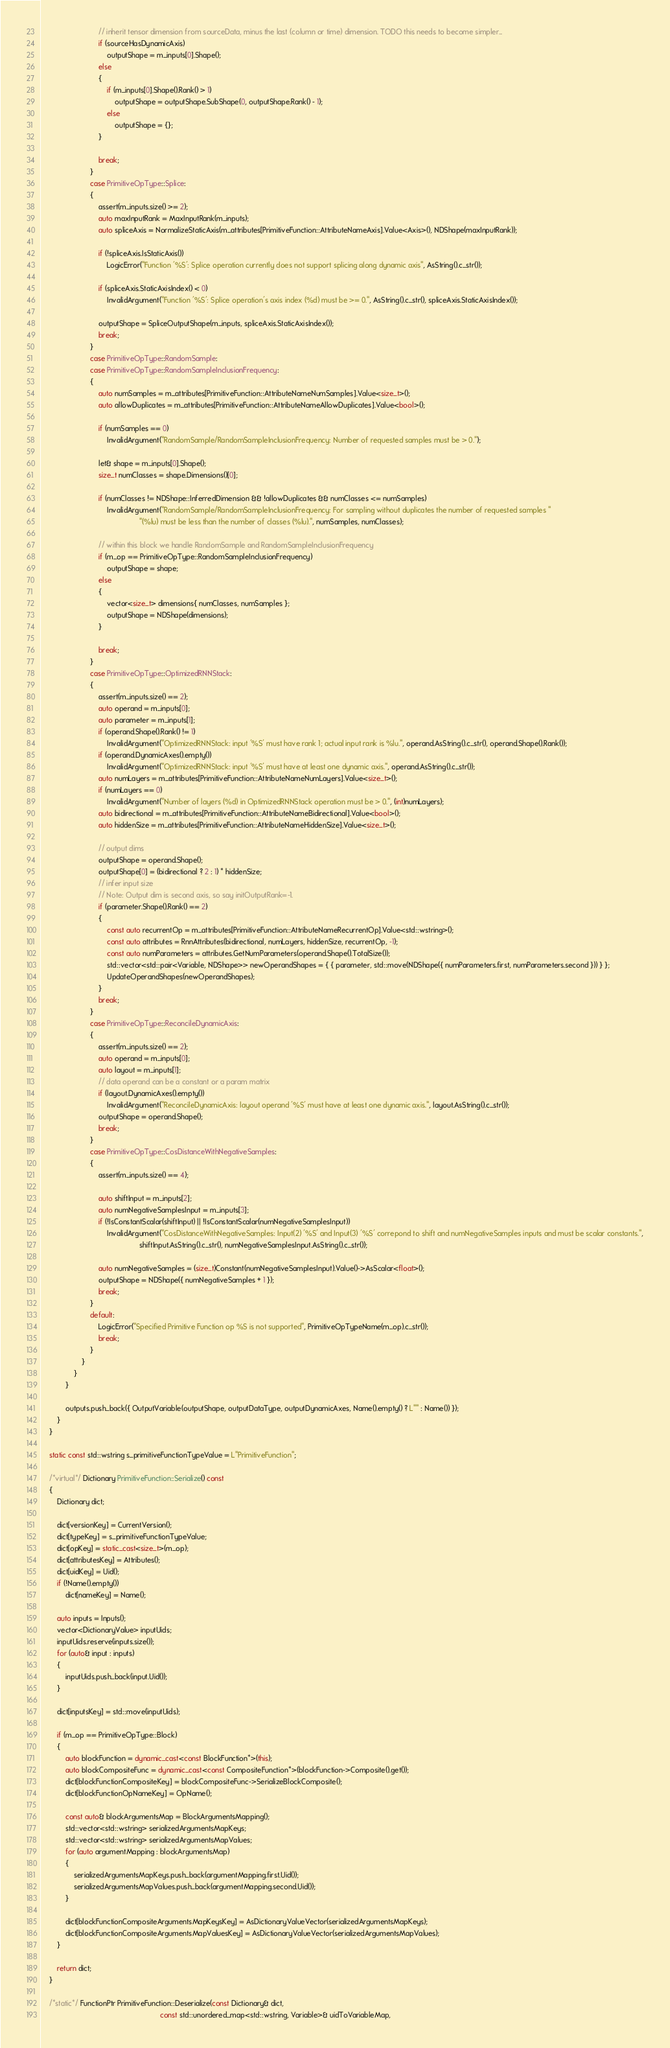<code> <loc_0><loc_0><loc_500><loc_500><_C++_>                            // inherit tensor dimension from sourceData, minus the last (column or time) dimension. TODO this needs to become simpler...
                            if (sourceHasDynamicAxis)
                                outputShape = m_inputs[0].Shape();
                            else
                            {
                                if (m_inputs[0].Shape().Rank() > 1)
                                    outputShape = outputShape.SubShape(0, outputShape.Rank() - 1);
                                else
                                    outputShape = {};
                            }

                            break;
                        }
                        case PrimitiveOpType::Splice:
                        {
                            assert(m_inputs.size() >= 2);
                            auto maxInputRank = MaxInputRank(m_inputs);
                            auto spliceAxis = NormalizeStaticAxis(m_attributes[PrimitiveFunction::AttributeNameAxis].Value<Axis>(), NDShape(maxInputRank));

                            if (!spliceAxis.IsStaticAxis())
                                LogicError("Function '%S': Splice operation currently does not support splicing along dynamic axis", AsString().c_str());

                            if (spliceAxis.StaticAxisIndex() < 0)
                                InvalidArgument("Function '%S': Splice operation's axis index (%d) must be >= 0.", AsString().c_str(), spliceAxis.StaticAxisIndex());

                            outputShape = SpliceOutputShape(m_inputs, spliceAxis.StaticAxisIndex());
                            break;
                        }
                        case PrimitiveOpType::RandomSample:
                        case PrimitiveOpType::RandomSampleInclusionFrequency:
                        {
                            auto numSamples = m_attributes[PrimitiveFunction::AttributeNameNumSamples].Value<size_t>();
                            auto allowDuplicates = m_attributes[PrimitiveFunction::AttributeNameAllowDuplicates].Value<bool>();

                            if (numSamples == 0)
                                InvalidArgument("RandomSample/RandomSampleInclusionFrequency: Number of requested samples must be > 0.");

                            let& shape = m_inputs[0].Shape();
                            size_t numClasses = shape.Dimensions()[0];

                            if (numClasses != NDShape::InferredDimension && !allowDuplicates && numClasses <= numSamples)
                                InvalidArgument("RandomSample/RandomSampleInclusionFrequency: For sampling without duplicates the number of requested samples "
                                                "(%lu) must be less than the number of classes (%lu).", numSamples, numClasses);

                            // within this block we handle RandomSample and RandomSampleInclusionFrequency
                            if (m_op == PrimitiveOpType::RandomSampleInclusionFrequency)
                                outputShape = shape;
                            else
                            {
                                vector<size_t> dimensions{ numClasses, numSamples };
                                outputShape = NDShape(dimensions);
                            }

                            break;
                        }
                        case PrimitiveOpType::OptimizedRNNStack:
                        {
                            assert(m_inputs.size() == 2);
                            auto operand = m_inputs[0];
                            auto parameter = m_inputs[1];
                            if (operand.Shape().Rank() != 1)
                                InvalidArgument("OptimizedRNNStack: input '%S' must have rank 1; actual input rank is %lu.", operand.AsString().c_str(), operand.Shape().Rank());
                            if (operand.DynamicAxes().empty())
                                InvalidArgument("OptimizedRNNStack: input '%S' must have at least one dynamic axis.", operand.AsString().c_str());
                            auto numLayers = m_attributes[PrimitiveFunction::AttributeNameNumLayers].Value<size_t>();
                            if (numLayers == 0)
                                InvalidArgument("Number of layers (%d) in OptimizedRNNStack operation must be > 0.", (int)numLayers);
                            auto bidirectional = m_attributes[PrimitiveFunction::AttributeNameBidirectional].Value<bool>();
                            auto hiddenSize = m_attributes[PrimitiveFunction::AttributeNameHiddenSize].Value<size_t>();

                            // output dims
                            outputShape = operand.Shape();
                            outputShape[0] = (bidirectional ? 2 : 1) * hiddenSize;
                            // infer input size
                            // Note: Output dim is second axis, so say initOutputRank=-1.
                            if (parameter.Shape().Rank() == 2)
                            {
                                const auto recurrentOp = m_attributes[PrimitiveFunction::AttributeNameRecurrentOp].Value<std::wstring>();
                                const auto attributes = RnnAttributes(bidirectional, numLayers, hiddenSize, recurrentOp, -1);
                                const auto numParameters = attributes.GetNumParameters(operand.Shape().TotalSize());
                                std::vector<std::pair<Variable, NDShape>> newOperandShapes = { { parameter, std::move(NDShape({ numParameters.first, numParameters.second })) } };
                                UpdateOperandShapes(newOperandShapes);
                            }
                            break;
                        }
                        case PrimitiveOpType::ReconcileDynamicAxis:
                        {
                            assert(m_inputs.size() == 2);
                            auto operand = m_inputs[0];
                            auto layout = m_inputs[1];
                            // data operand can be a constant or a param matrix
                            if (layout.DynamicAxes().empty())
                                InvalidArgument("ReconcileDynamicAxis: layout operand '%S' must have at least one dynamic axis.", layout.AsString().c_str());
                            outputShape = operand.Shape();
                            break;
                        }
                        case PrimitiveOpType::CosDistanceWithNegativeSamples:
                        {
                            assert(m_inputs.size() == 4);

                            auto shiftInput = m_inputs[2];
                            auto numNegativeSamplesInput = m_inputs[3];
                            if (!IsConstantScalar(shiftInput) || !IsConstantScalar(numNegativeSamplesInput))
                                InvalidArgument("CosDistanceWithNegativeSamples: Input(2) '%S' and Input(3) '%S' correpond to shift and numNegativeSamples inputs and must be scalar constants.",
                                                shiftInput.AsString().c_str(), numNegativeSamplesInput.AsString().c_str());

                            auto numNegativeSamples = (size_t)Constant(numNegativeSamplesInput).Value()->AsScalar<float>();
                            outputShape = NDShape({ numNegativeSamples + 1 });
                            break;
                        }
                        default:
                            LogicError("Specified Primitive Function op %S is not supported", PrimitiveOpTypeName(m_op).c_str());
                            break;
                        }
                    }
                }
            }

            outputs.push_back({ OutputVariable(outputShape, outputDataType, outputDynamicAxes, Name().empty() ? L"" : Name()) });
        }
    }

    static const std::wstring s_primitiveFunctionTypeValue = L"PrimitiveFunction";

    /*virtual*/ Dictionary PrimitiveFunction::Serialize() const 
    {
        Dictionary dict;

        dict[versionKey] = CurrentVersion();
        dict[typeKey] = s_primitiveFunctionTypeValue;
        dict[opKey] = static_cast<size_t>(m_op);
        dict[attributesKey] = Attributes();
        dict[uidKey] = Uid();
        if (!Name().empty())
            dict[nameKey] = Name();
        
        auto inputs = Inputs();
        vector<DictionaryValue> inputUids;
        inputUids.reserve(inputs.size());
        for (auto& input : inputs)
        {
            inputUids.push_back(input.Uid());
        }

        dict[inputsKey] = std::move(inputUids);

        if (m_op == PrimitiveOpType::Block)
        {
            auto blockFunction = dynamic_cast<const BlockFunction*>(this);
            auto blockCompositeFunc = dynamic_cast<const CompositeFunction*>(blockFunction->Composite().get());
            dict[blockFunctionCompositeKey] = blockCompositeFunc->SerializeBlockComposite();
            dict[blockFunctionOpNameKey] = OpName();

            const auto& blockArgumentsMap = BlockArgumentsMapping();
            std::vector<std::wstring> serializedArgumentsMapKeys;
            std::vector<std::wstring> serializedArgumentsMapValues;
            for (auto argumentMapping : blockArgumentsMap)
            {
                serializedArgumentsMapKeys.push_back(argumentMapping.first.Uid());
                serializedArgumentsMapValues.push_back(argumentMapping.second.Uid());
            }

            dict[blockFunctionCompositeArgumentsMapKeysKey] = AsDictionaryValueVector(serializedArgumentsMapKeys);
            dict[blockFunctionCompositeArgumentsMapValuesKey] = AsDictionaryValueVector(serializedArgumentsMapValues);
        }

        return dict;
    }

    /*static*/ FunctionPtr PrimitiveFunction::Deserialize(const Dictionary& dict, 
                                                          const std::unordered_map<std::wstring, Variable>& uidToVariableMap,</code> 